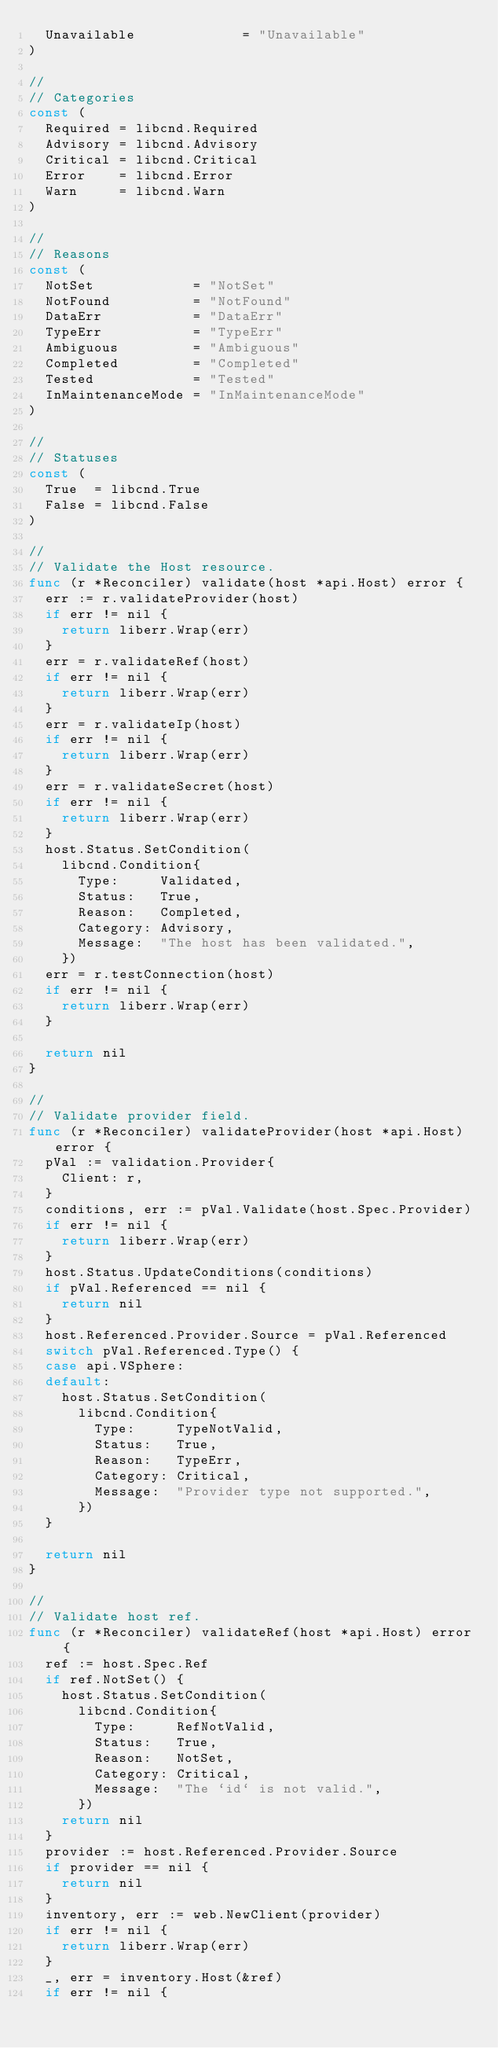<code> <loc_0><loc_0><loc_500><loc_500><_Go_>	Unavailable             = "Unavailable"
)

//
// Categories
const (
	Required = libcnd.Required
	Advisory = libcnd.Advisory
	Critical = libcnd.Critical
	Error    = libcnd.Error
	Warn     = libcnd.Warn
)

//
// Reasons
const (
	NotSet            = "NotSet"
	NotFound          = "NotFound"
	DataErr           = "DataErr"
	TypeErr           = "TypeErr"
	Ambiguous         = "Ambiguous"
	Completed         = "Completed"
	Tested            = "Tested"
	InMaintenanceMode = "InMaintenanceMode"
)

//
// Statuses
const (
	True  = libcnd.True
	False = libcnd.False
)

//
// Validate the Host resource.
func (r *Reconciler) validate(host *api.Host) error {
	err := r.validateProvider(host)
	if err != nil {
		return liberr.Wrap(err)
	}
	err = r.validateRef(host)
	if err != nil {
		return liberr.Wrap(err)
	}
	err = r.validateIp(host)
	if err != nil {
		return liberr.Wrap(err)
	}
	err = r.validateSecret(host)
	if err != nil {
		return liberr.Wrap(err)
	}
	host.Status.SetCondition(
		libcnd.Condition{
			Type:     Validated,
			Status:   True,
			Reason:   Completed,
			Category: Advisory,
			Message:  "The host has been validated.",
		})
	err = r.testConnection(host)
	if err != nil {
		return liberr.Wrap(err)
	}

	return nil
}

//
// Validate provider field.
func (r *Reconciler) validateProvider(host *api.Host) error {
	pVal := validation.Provider{
		Client: r,
	}
	conditions, err := pVal.Validate(host.Spec.Provider)
	if err != nil {
		return liberr.Wrap(err)
	}
	host.Status.UpdateConditions(conditions)
	if pVal.Referenced == nil {
		return nil
	}
	host.Referenced.Provider.Source = pVal.Referenced
	switch pVal.Referenced.Type() {
	case api.VSphere:
	default:
		host.Status.SetCondition(
			libcnd.Condition{
				Type:     TypeNotValid,
				Status:   True,
				Reason:   TypeErr,
				Category: Critical,
				Message:  "Provider type not supported.",
			})
	}

	return nil
}

//
// Validate host ref.
func (r *Reconciler) validateRef(host *api.Host) error {
	ref := host.Spec.Ref
	if ref.NotSet() {
		host.Status.SetCondition(
			libcnd.Condition{
				Type:     RefNotValid,
				Status:   True,
				Reason:   NotSet,
				Category: Critical,
				Message:  "The `id` is not valid.",
			})
		return nil
	}
	provider := host.Referenced.Provider.Source
	if provider == nil {
		return nil
	}
	inventory, err := web.NewClient(provider)
	if err != nil {
		return liberr.Wrap(err)
	}
	_, err = inventory.Host(&ref)
	if err != nil {</code> 